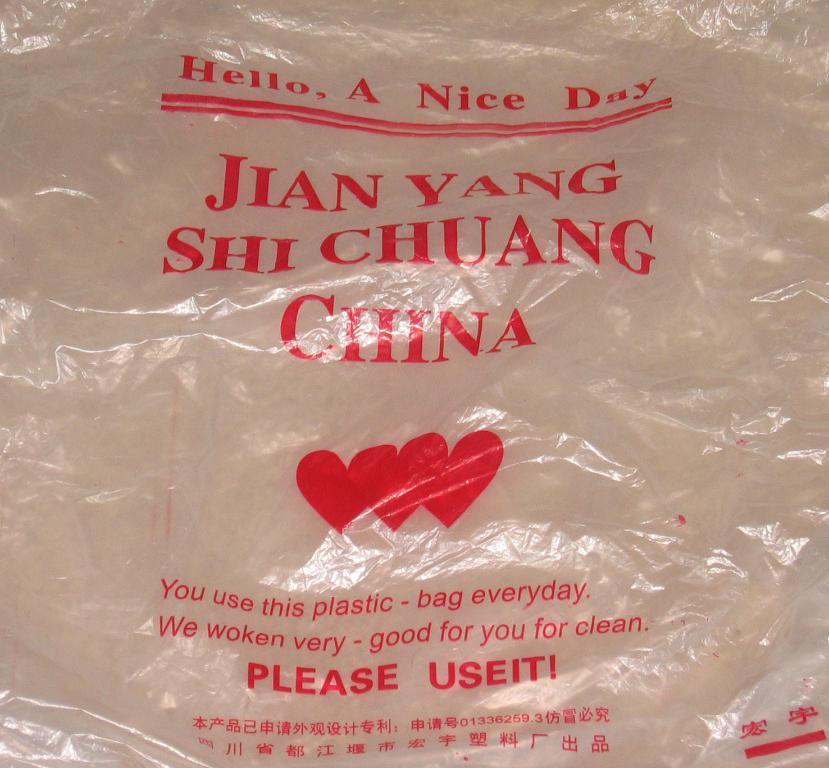Describe this image in one or two sentences. In this picture we can see a polythene cover and on the cover, it is written with red color and there are heart shape symbols on it. 